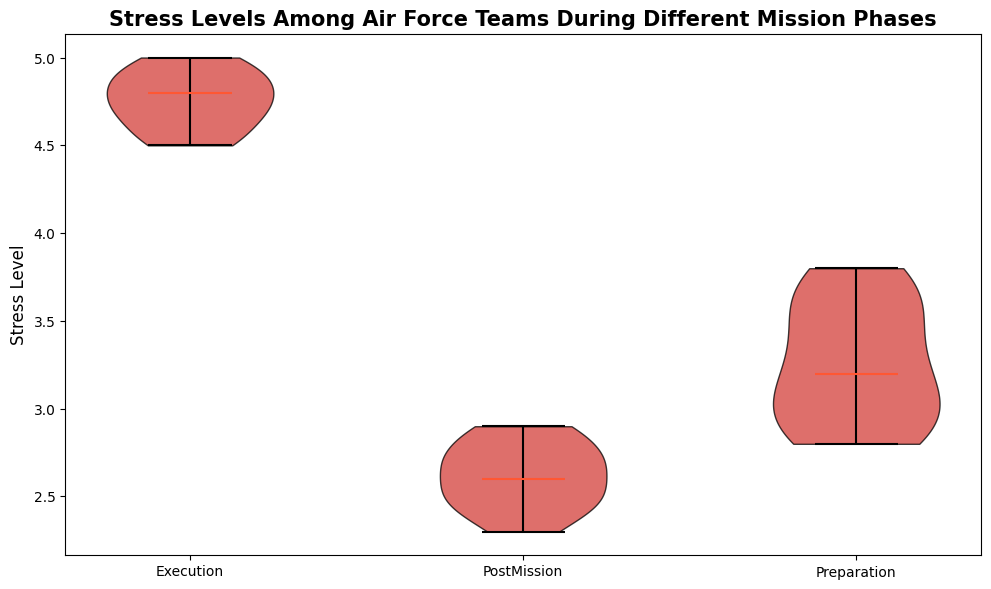What is the median stress level during the Execution phase? To find the median stress level for the Execution phase, look at the middle value of the Execution data segment on the plot. The violin plot shows the median with a horizontal line.
Answer: 4.8 Which mission phase has the lowest median stress level? Look for the mission phase with the horizontal median line positioned at the lowest stress level. The PostMission phase has the lowest median.
Answer: PostMission How do the stress level ranges compare between the Preparation and Execution phases? Compare the height of the violins representing each phase. The Preparation phase ranges approximately from 2.8 to 3.8, whereas the Execution phase ranges from 4.5 to 5.0, indicating a higher stress level in the Execution phase.
Answer: Execution phase has a higher range What is the difference between the highest stress level during Execution and the highest stress level during PostMission? Identify the topmost points in the Execution and PostMission violins. The highest stress level during Execution is 5.0, and during PostMission is 2.9. Subtract 2.9 from 5.0 to get the difference.
Answer: 2.1 Which phase shows greater variation in stress levels? Look at the width and spread of the violins. Greater variation is indicated by a more spread-out distribution. The Execution phase violin is the widest and most spread out, indicating greater variation.
Answer: Execution How does the median stress level during Preparation compare to PostMission? Compare the horizontal median lines. Preparation has a median stress level around 3.3, while PostMission is around 2.6. Preparation has a higher median than PostMission.
Answer: Preparation has a higher median What is the color used in the violins and what does it signify? All the violins use a reddish color filled with a gradient. Colors in this context likely signify the stress levels but are mainly for visual appeal and uniformity.
Answer: Red, visual uniformity Which mission phase has the closest upper and lower quartiles, indicating less spread? Look for the phase where the edges of the main part of the violin are closer together. The PostMission phase shows the least spread, indicated by closely packed quartile edges.
Answer: PostMission What is the median stress level difference between Preparation and Execution? The median for Preparation is approximately 3.3 and for Execution is 4.8. Subtracting 3.3 from 4.8 gives a median difference of 1.5.
Answer: 1.5 What is the overall trend in the stress levels across the mission phases? Examine the position and height of the violins. Stress levels increase from Preparation to Execution and then decrease in the PostMission phase, indicating higher stress during active missions and lower stress afterward.
Answer: Increase during Execution, then decrease 